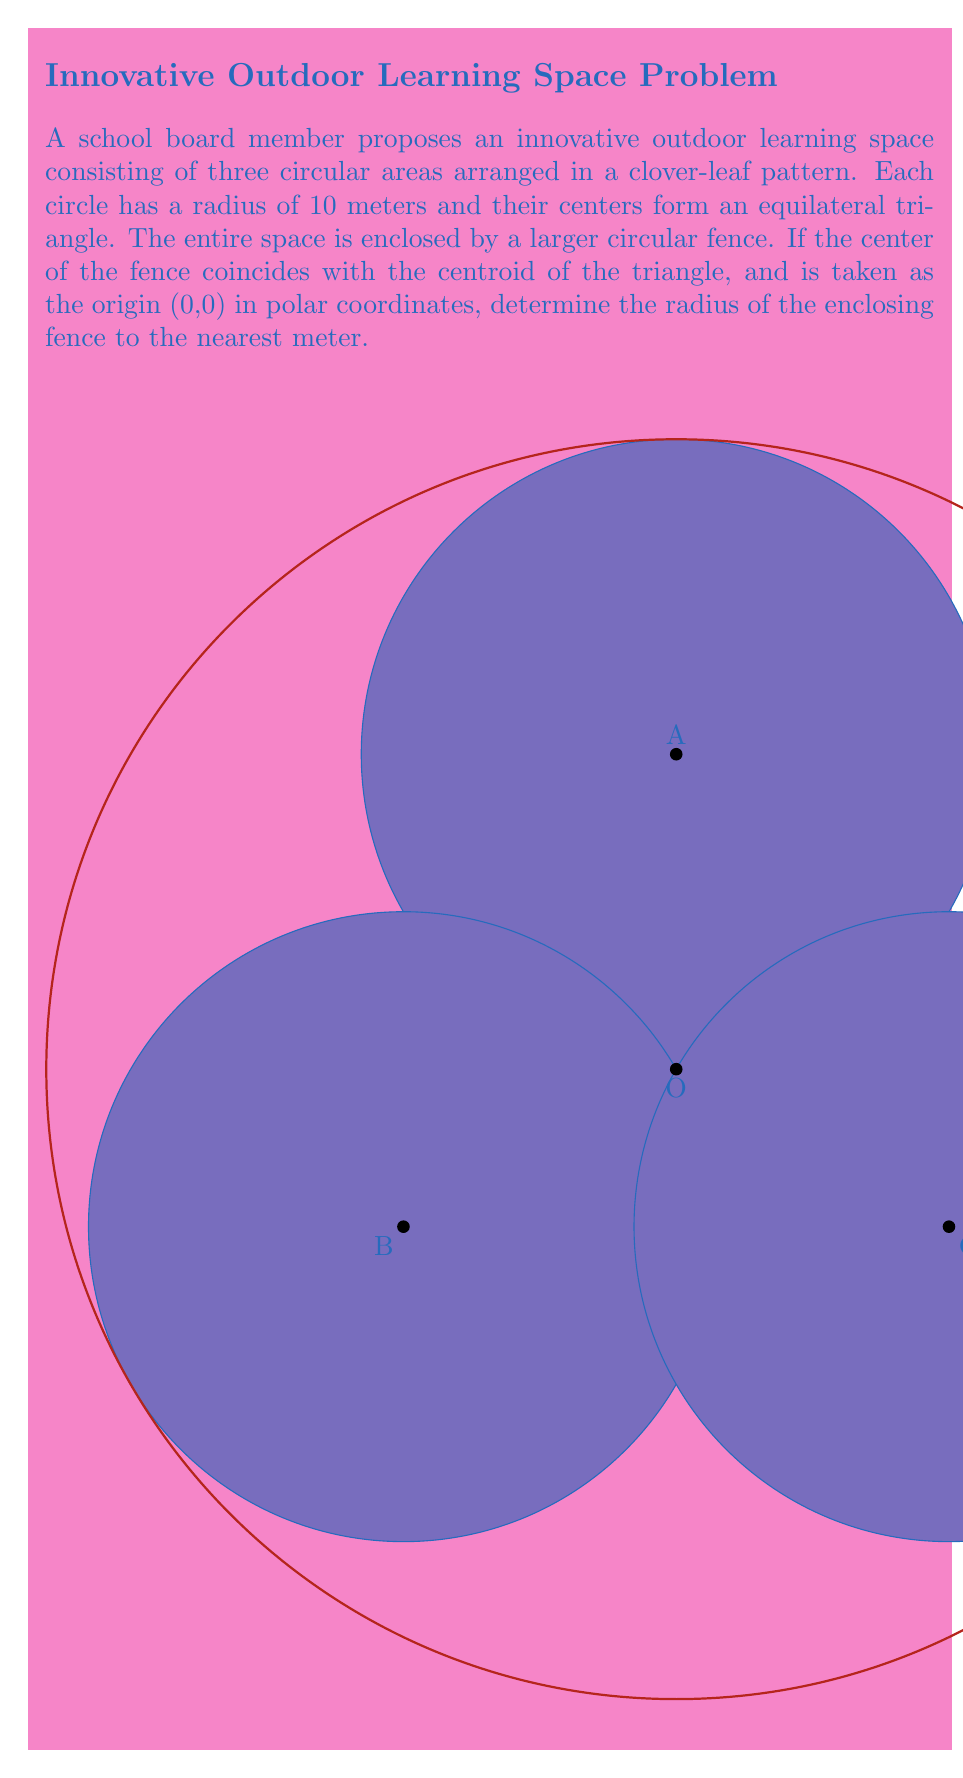Solve this math problem. Let's approach this step-by-step:

1) In an equilateral triangle, the centroid divides each median in the ratio 2:1. This means the distance from the centroid to any vertex is 2/3 of the distance from the centroid to the midpoint of the opposite side.

2) Let's denote the side length of the equilateral triangle as $a$. The distance from the centroid to a vertex is then $\frac{a\sqrt{3}}{3}$.

3) In polar coordinates, the vertices of the triangle can be represented as:
   A: $(r,\theta) = (\frac{a\sqrt{3}}{3}, \frac{\pi}{2})$
   B: $(r,\theta) = (\frac{a\sqrt{3}}{3}, \frac{7\pi}{6})$
   C: $(r,\theta) = (\frac{a\sqrt{3}}{3}, \frac{11\pi}{6})$

4) The radius of the enclosing fence must be large enough to encompass all three circles. The furthest point of any circle from the origin will be at a distance of $\frac{a\sqrt{3}}{3} + 10$ (the distance to the center plus the radius of the circle).

5) To find $a$, we can use the fact that the distance between any two vertices is 20 (twice the radius of a circle). Using the distance formula in polar coordinates:

   $$20^2 = (\frac{a\sqrt{3}}{3})^2 + (\frac{a\sqrt{3}}{3})^2 - 2(\frac{a\sqrt{3}}{3})^2 \cos(\frac{2\pi}{3})$$

6) Simplifying:
   $$400 = \frac{2a^2}{3} + \frac{a^2}{3} = a^2$$
   $$a = 20$$

7) Therefore, the distance from the origin to the furthest point of any circle is:

   $$\frac{20\sqrt{3}}{3} + 10 \approx 21.55$$

8) Rounding to the nearest meter gives us 22 meters.
Answer: 22 meters 